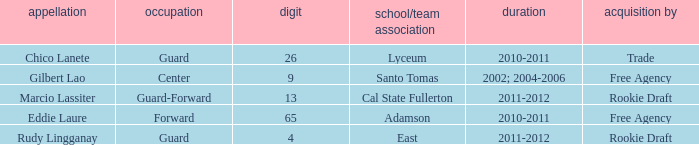What season had an acquisition of free agency, and was higher than 9? 2010-2011. 